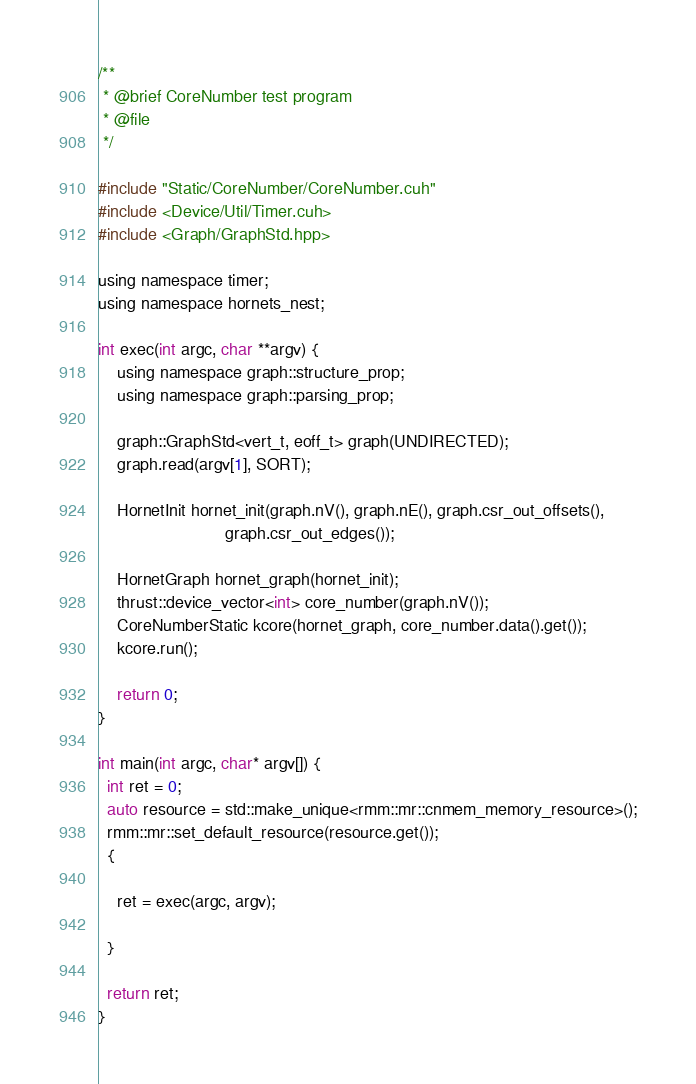<code> <loc_0><loc_0><loc_500><loc_500><_Cuda_>
/**
 * @brief CoreNumber test program
 * @file
 */

#include "Static/CoreNumber/CoreNumber.cuh"
#include <Device/Util/Timer.cuh>
#include <Graph/GraphStd.hpp>

using namespace timer;
using namespace hornets_nest;

int exec(int argc, char **argv) {
    using namespace graph::structure_prop;
    using namespace graph::parsing_prop;

    graph::GraphStd<vert_t, eoff_t> graph(UNDIRECTED);
    graph.read(argv[1], SORT);

    HornetInit hornet_init(graph.nV(), graph.nE(), graph.csr_out_offsets(),
                           graph.csr_out_edges());

    HornetGraph hornet_graph(hornet_init);
    thrust::device_vector<int> core_number(graph.nV());
    CoreNumberStatic kcore(hornet_graph, core_number.data().get());
    kcore.run();

    return 0;
}

int main(int argc, char* argv[]) {
  int ret = 0;
  auto resource = std::make_unique<rmm::mr::cnmem_memory_resource>();
  rmm::mr::set_default_resource(resource.get());
  {

    ret = exec(argc, argv);

  }

  return ret;
}
</code> 